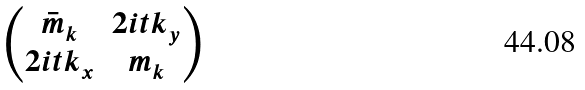Convert formula to latex. <formula><loc_0><loc_0><loc_500><loc_500>\begin{pmatrix} \bar { m } _ { k } & 2 i t k _ { y } \\ 2 i t k _ { x } & m _ { k } \end{pmatrix}</formula> 